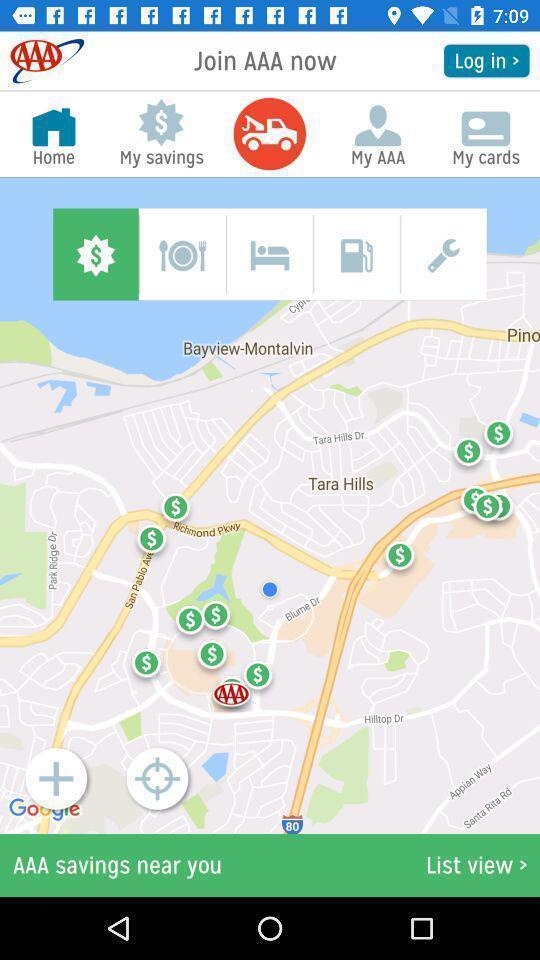What details can you identify in this image? Screen displaying a map view with multiple controls. 